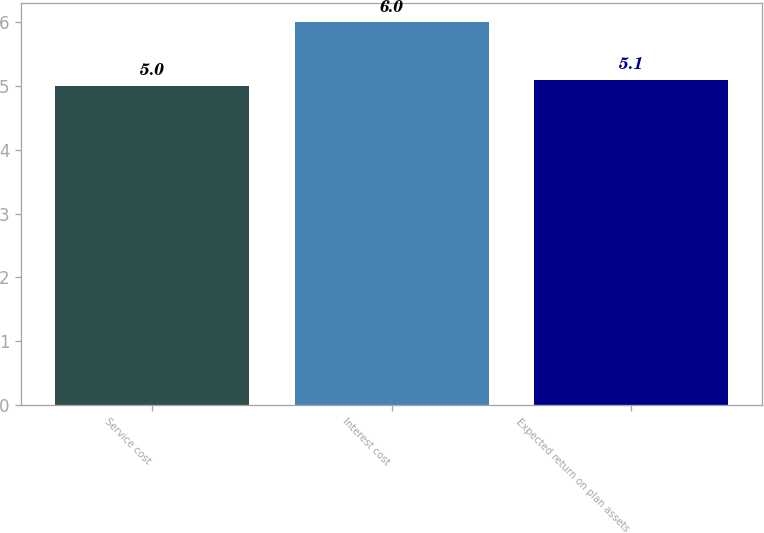<chart> <loc_0><loc_0><loc_500><loc_500><bar_chart><fcel>Service cost<fcel>Interest cost<fcel>Expected return on plan assets<nl><fcel>5<fcel>6<fcel>5.1<nl></chart> 